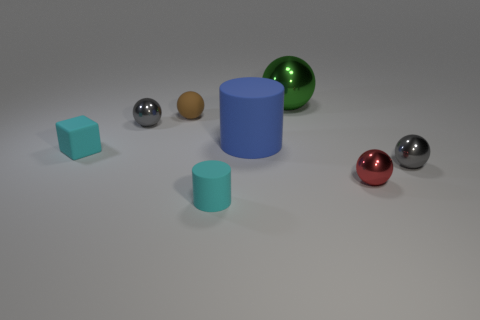Are there any other things that have the same shape as the red shiny thing?
Ensure brevity in your answer.  Yes. How big is the gray shiny thing behind the tiny block?
Ensure brevity in your answer.  Small. What number of other objects are there of the same color as the small matte sphere?
Keep it short and to the point. 0. The small gray object on the right side of the cyan thing in front of the small red metallic thing is made of what material?
Provide a short and direct response. Metal. Do the tiny rubber object left of the small matte ball and the tiny cylinder have the same color?
Give a very brief answer. Yes. How many red metallic things are the same shape as the brown object?
Offer a terse response. 1. What size is the blue cylinder that is made of the same material as the brown sphere?
Offer a terse response. Large. Are there any big blue things behind the small matte sphere that is behind the gray metal sphere that is on the left side of the big rubber object?
Your answer should be very brief. No. Do the gray metallic sphere that is on the left side of the matte ball and the small cyan cylinder have the same size?
Provide a succinct answer. Yes. How many blue cylinders have the same size as the green metal ball?
Provide a short and direct response. 1. 